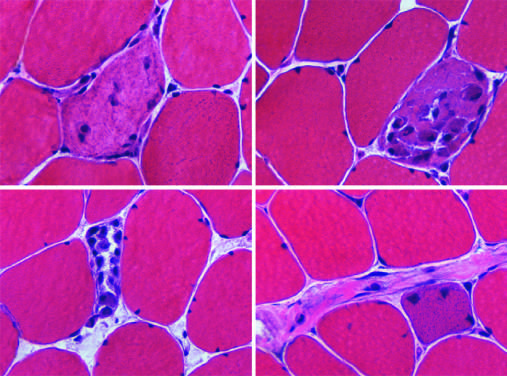what are associated with segmental necrosis and regeneration of individual myofibers?
Answer the question using a single word or phrase. Myopathic conditions 